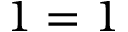<formula> <loc_0><loc_0><loc_500><loc_500>1 = 1</formula> 